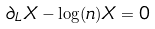<formula> <loc_0><loc_0><loc_500><loc_500>\partial _ { L } X - \log ( n ) X = 0</formula> 